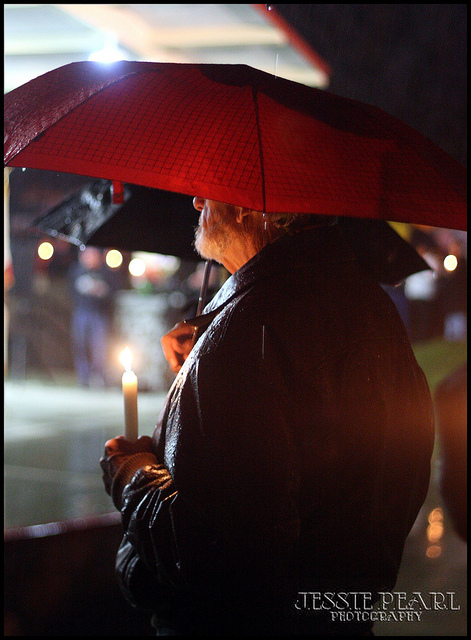<image>Is the person under the umbrella praying with a candle in his hand? I don't know if the person under the umbrella is praying with a candle in his hand. Is the person under the umbrella praying with a candle in his hand? I am not sure if the person under the umbrella is praying with a candle in his hand. However, it can be seen "yes" in the answers. 